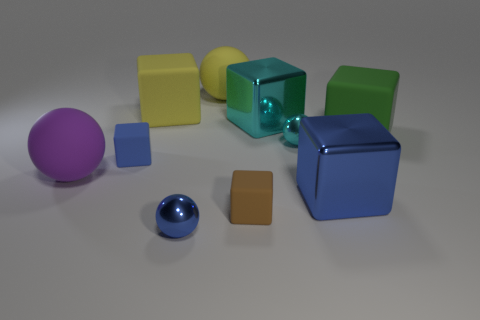Is the big green block made of the same material as the cyan object that is behind the cyan shiny ball?
Provide a succinct answer. No. What number of objects are tiny yellow metallic things or large matte balls?
Provide a short and direct response. 2. Does the rubber cube that is in front of the large blue thing have the same size as the blue object that is in front of the brown rubber cube?
Your answer should be compact. Yes. How many cylinders are big shiny things or purple matte things?
Provide a succinct answer. 0. Are there any large purple matte things?
Your answer should be compact. Yes. Is there any other thing that is the same shape as the large green object?
Keep it short and to the point. Yes. What number of objects are large blocks in front of the large cyan thing or small balls?
Provide a short and direct response. 4. What number of big blocks are to the right of the tiny metal object that is behind the tiny rubber thing in front of the large blue shiny cube?
Make the answer very short. 2. Is there any other thing that has the same size as the brown matte cube?
Your answer should be very brief. Yes. The big metal object in front of the thing to the left of the tiny cube that is behind the tiny brown matte cube is what shape?
Your answer should be compact. Cube. 